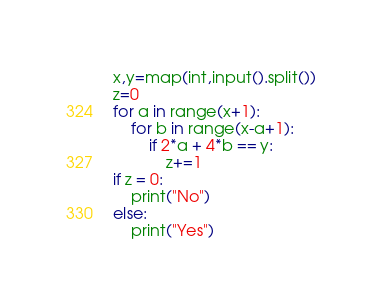Convert code to text. <code><loc_0><loc_0><loc_500><loc_500><_Python_>x,y=map(int,input().split())
z=0
for a in range(x+1):
	for b in range(x-a+1):
		if 2*a + 4*b == y:
			z+=1
if z = 0:
	print("No")
else:
	print("Yes")</code> 